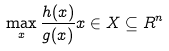Convert formula to latex. <formula><loc_0><loc_0><loc_500><loc_500>\max _ { x } \frac { h ( x ) } { g ( x ) } x \in X \subseteq R ^ { n }</formula> 